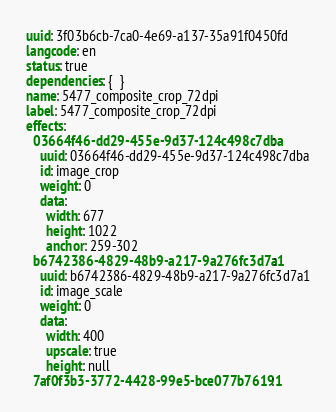Convert code to text. <code><loc_0><loc_0><loc_500><loc_500><_YAML_>uuid: 3f03b6cb-7ca0-4e69-a137-35a91f0450fd
langcode: en
status: true
dependencies: {  }
name: 5477_composite_crop_72dpi
label: 5477_composite_crop_72dpi
effects:
  03664f46-dd29-455e-9d37-124c498c7dba:
    uuid: 03664f46-dd29-455e-9d37-124c498c7dba
    id: image_crop
    weight: 0
    data:
      width: 677
      height: 1022
      anchor: 259-302
  b6742386-4829-48b9-a217-9a276fc3d7a1:
    uuid: b6742386-4829-48b9-a217-9a276fc3d7a1
    id: image_scale
    weight: 0
    data:
      width: 400
      upscale: true
      height: null
  7af0f3b3-3772-4428-99e5-bce077b76191:</code> 